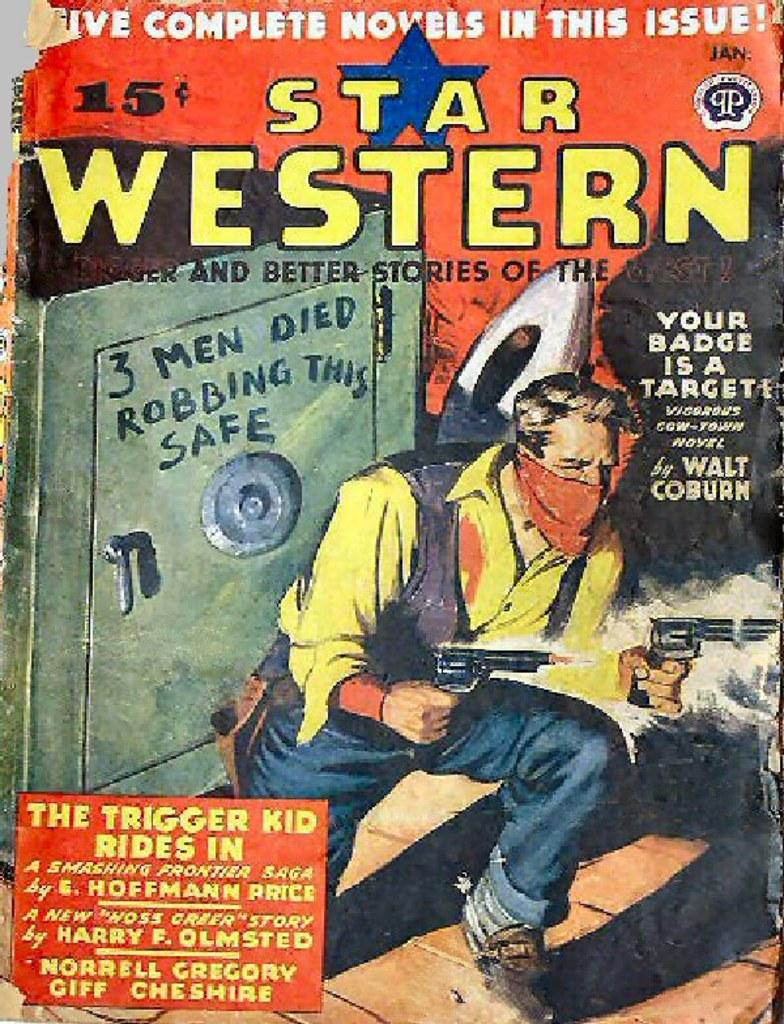<image>
Offer a succinct explanation of the picture presented. The cover of a Star Western book features a man holding a gun. 